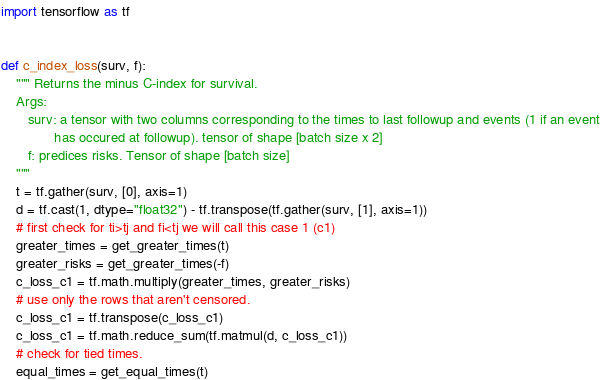Convert code to text. <code><loc_0><loc_0><loc_500><loc_500><_Python_>import tensorflow as tf


def c_index_loss(surv, f):
    """ Returns the minus C-index for survival.
    Args:
       surv: a tensor with two columns corresponding to the times to last followup and events (1 if an event
              has occured at followup). tensor of shape [batch size x 2]
       f: predices risks. Tensor of shape [batch size]
    """
    t = tf.gather(surv, [0], axis=1)
    d = tf.cast(1, dtype="float32") - tf.transpose(tf.gather(surv, [1], axis=1))
    # first check for ti>tj and fi<tj we will call this case 1 (c1)
    greater_times = get_greater_times(t)
    greater_risks = get_greater_times(-f)
    c_loss_c1 = tf.math.multiply(greater_times, greater_risks)
    # use only the rows that aren't censored.
    c_loss_c1 = tf.transpose(c_loss_c1)
    c_loss_c1 = tf.math.reduce_sum(tf.matmul(d, c_loss_c1))
    # check for tied times.
    equal_times = get_equal_times(t)</code> 